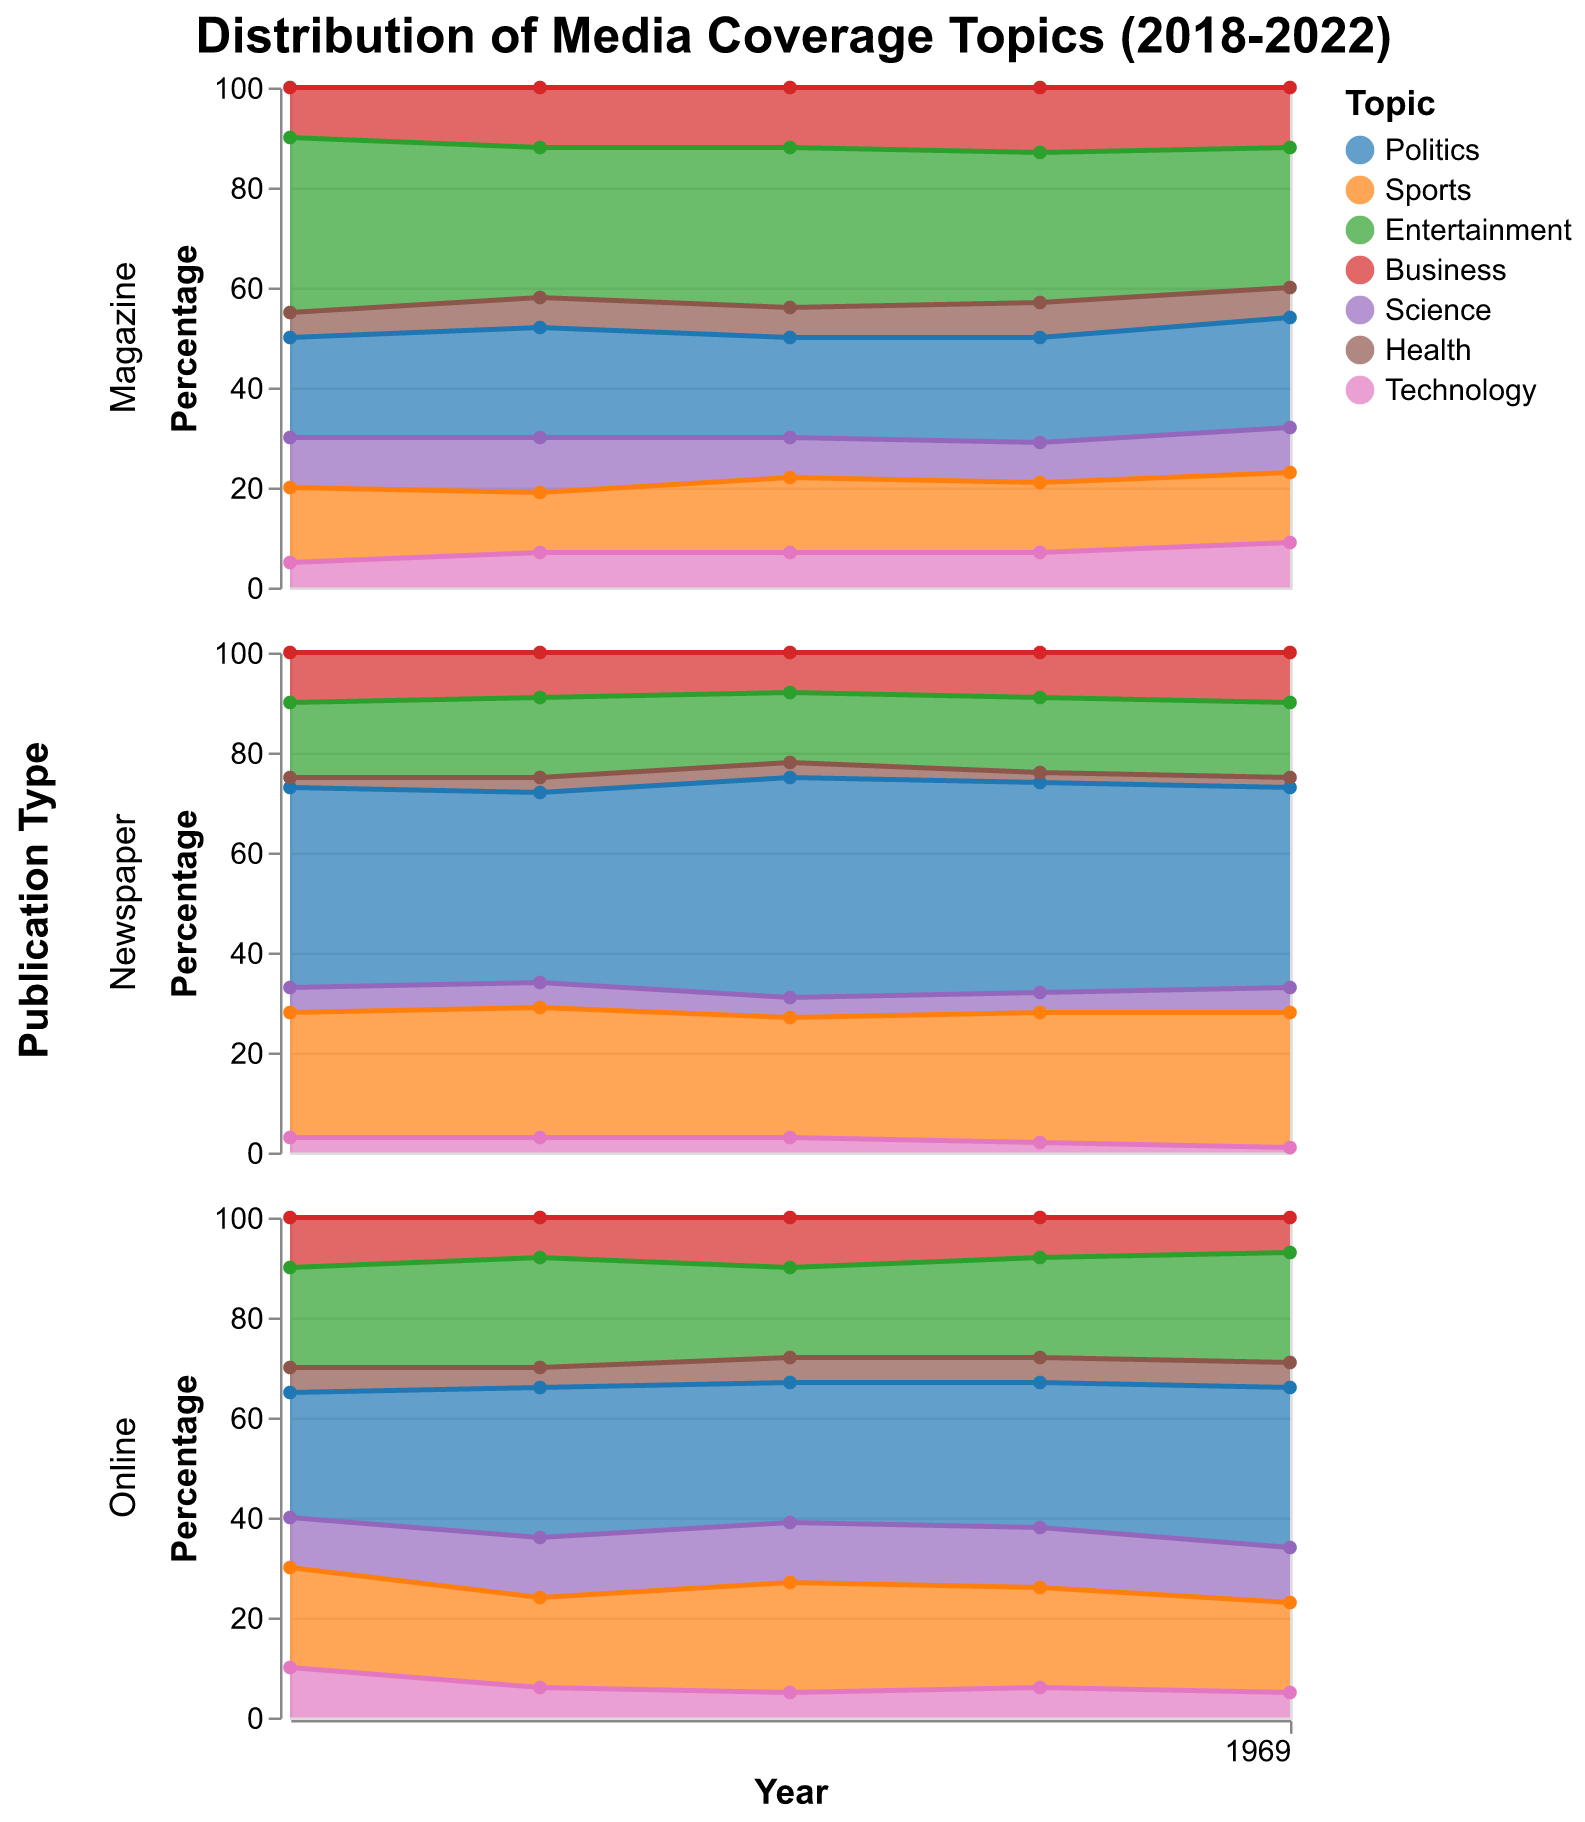What is the overall trend in the coverage of politics in newspapers between 2018 and 2022? To find the overall trend, look at the percentage of politics coverage in newspapers over each year from 2018 to 2022. Starting at 40% in 2018, the data shows it fluctuates slightly, hitting a high of 44% in 2020 and eventually returning to 40% in 2022.
Answer: Relatively stable with minor fluctuations Which publication type had the highest percentage of entertainment coverage in 2018? Examine the percentages for entertainment coverage across different publication types in 2018. Newspapers had 15%, Magazines had 35%, and Online had 20%. Hence, Magazines had the highest percentage.
Answer: Magazines How did the coverage of technology topics in online publications change from 2018 to 2022? Look at the percentage of coverage of technology in online publications for each year. It starts at 10% in 2018, decreases to 6% in 2019, 5% in 2020, then remains constant at 5% in 2021, and finally back to 5% in 2022.
Answer: Decreased and then remained stable Compare the coverage of sports in magazines versus newspapers in 2022. Which has more coverage? Check the percentages for sports in both magazines and newspapers in 2022. Magazines have 14%, whereas Newspapers have 27%. Therefore, coverage of sports is higher in newspapers.
Answer: Newspapers What is the average percentage of business coverage in magazines from 2018 to 2022? Sum the percentages of business coverage in magazines for each year (10% in 2018, 12% in 2019, 12% in 2020, 13% in 2021, and 12% in 2022), and then divide by the number of years (5). (10 + 12 + 12 + 13 + 12) / 5 = 59 / 5 = 11.8%
Answer: 11.8% Which publication type showed a consistent decline in health coverage from 2018 to 2022? Examine the health coverage percentages for each publication type across the years. Newspapers start at 2% in 2018, remain at 2% until 2022, making it constant rather than declining. Magazines start at 5%, go up to 7% in 2021, and down to 6% in 2022, indicating inconsistency. Online starts at 5%, drops to 4% in 2019, recovers to 5%, and stays constant. Thus, none consistently declined.
Answer: None Which topic in online publications saw the most significant growth between 2018 and 2022? Compare the percentages of all topics in online publications from 2018 to 2022. Politics grew from 25% to 32%, technology saw a drop, health remained consistent, etc. The topic with the most noticeable growth is politics (from 25% to 32%).
Answer: Politics Is there a publication type where science coverage decreased over the observed period? Analyze the percentage data for science coverage across the years. Newspapers have a consistent or slightly increasing trend. In magazines, it decreases from 10% in 2018 to 9% in 2022. Online shows a minor decrease from 12% to 11%.
Answer: Magazines How does the coverage of sports in online publications in 2021 compare to that in 2022? Identify the percentages for sports coverage in online publications for 2021 and 2022. The data shows 20% in 2021 and 18% in 2022, indicating a decrease.
Answer: Decreased What was the most covered topic in newspapers in 2019, and what percentage did it cover? Assess the topic coverage percentages for newspapers in 2019. Politics is the highest at 38%.
Answer: Politics, 38% 